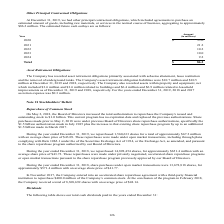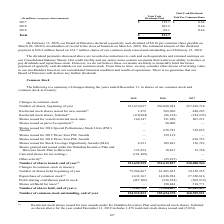According to Sealed Air Corporation's financial document, What is the Total Cash Dividends Paid for 2017? According to the financial document, $119.7 (in millions). The relevant text states: "2017 $ 119.7 $ 0.64..." Also, What years are included in the table? The document contains multiple relevant values: 2017, 2018, 2019. From the document: ". For the years ended December 31, 2019, 2018 and 2017 accretion expense was $0.3 million. 2019 99.1 0.64 2018 102.9 0.64..." Also, What did the Board of Directors declare on February 13, 2020? a quarterly cash dividend of $0.16 per common share payable on March 20, 2020 to stockholders of record at the close of business on March 6, 2020.. The document states: "February 13, 2020, our Board of Directors declared a quarterly cash dividend of $0.16 per common share payable on March 20, 2020 to stockholders of re..." Also, can you calculate: What is the total cash dividends paid for 2019 expressed as percentage of the total cash dividends paid for all years? Based on the calculation: 99.1/321.7, the result is 30.81 (percentage). This is based on the information: "Total $ 321.7 2019 99.1 0.64..." The key data points involved are: 321.7, 99.1. Also, can you calculate: About how many common shares were there in total for all years? Based on the calculation: 321.7/0.64, the result is 502.66 (in millions). This is based on the information: "2017 $ 119.7 $ 0.64 Total $ 321.7..." The key data points involved are: 0.64, 321.7. Also, can you calculate: Including the declared quarterly cash dividend on February 13, 2020, what is the Total Cash Dividends Paid as of February 21, 2020 in dollars? Based on the calculation: 321.7+24.8, the result is 346.5 (in millions). This is based on the information: "Total $ 321.7 The estimated amount of this dividend payment is $24.8 million based on 154.7 million shares of our common stock issued and outstanding as of February 21,..." The key data points involved are: 24.8, 321.7. 